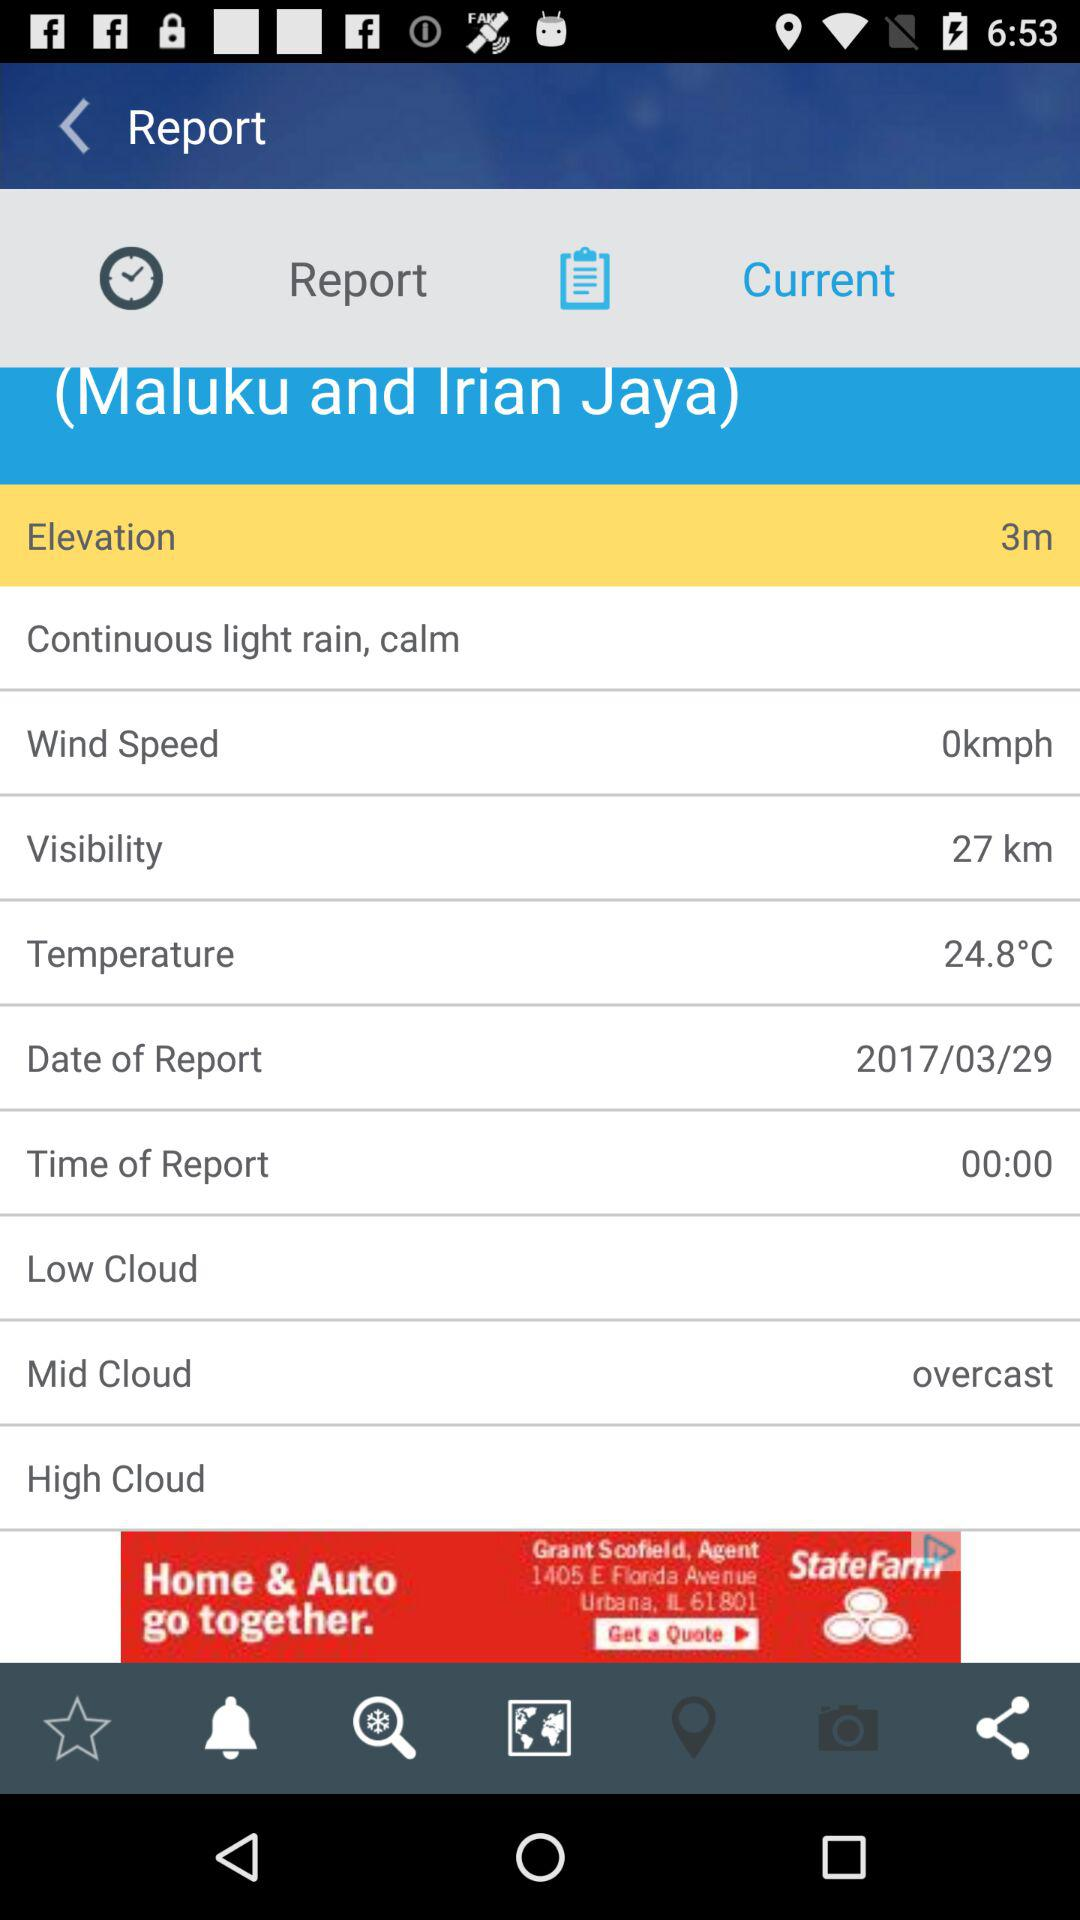What is the temperature of the air?
Answer the question using a single word or phrase. 24.8°C 